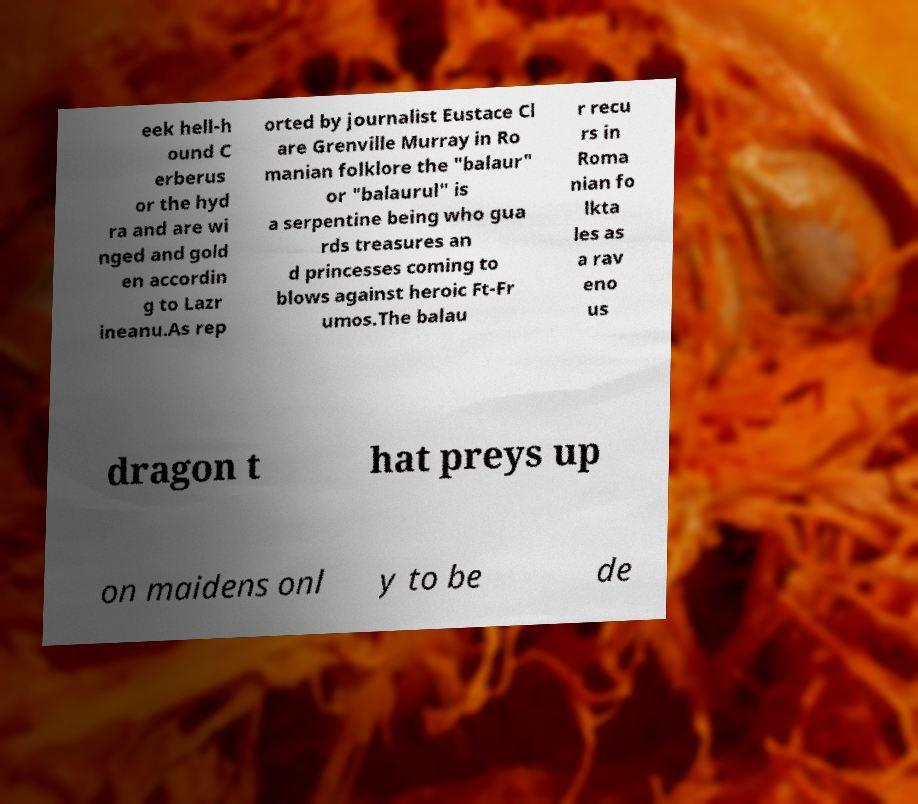Could you assist in decoding the text presented in this image and type it out clearly? eek hell-h ound C erberus or the hyd ra and are wi nged and gold en accordin g to Lazr ineanu.As rep orted by journalist Eustace Cl are Grenville Murray in Ro manian folklore the "balaur" or "balaurul" is a serpentine being who gua rds treasures an d princesses coming to blows against heroic Ft-Fr umos.The balau r recu rs in Roma nian fo lkta les as a rav eno us dragon t hat preys up on maidens onl y to be de 